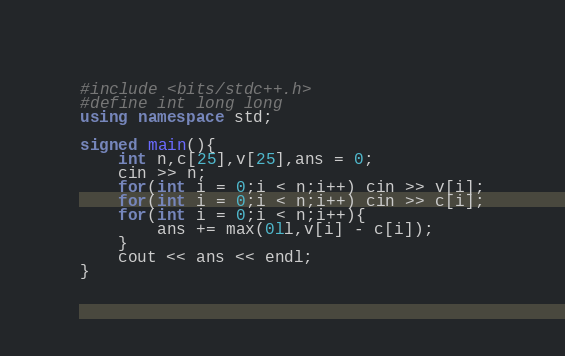<code> <loc_0><loc_0><loc_500><loc_500><_C++_>#include <bits/stdc++.h>
#define int long long
using namespace std;

signed main(){
	int n,c[25],v[25],ans = 0;
	cin >> n;
	for(int i = 0;i < n;i++) cin >> v[i];
	for(int i = 0;i < n;i++) cin >> c[i];
	for(int i = 0;i < n;i++){
		ans += max(0ll,v[i] - c[i]);
	}
	cout << ans << endl;
}</code> 